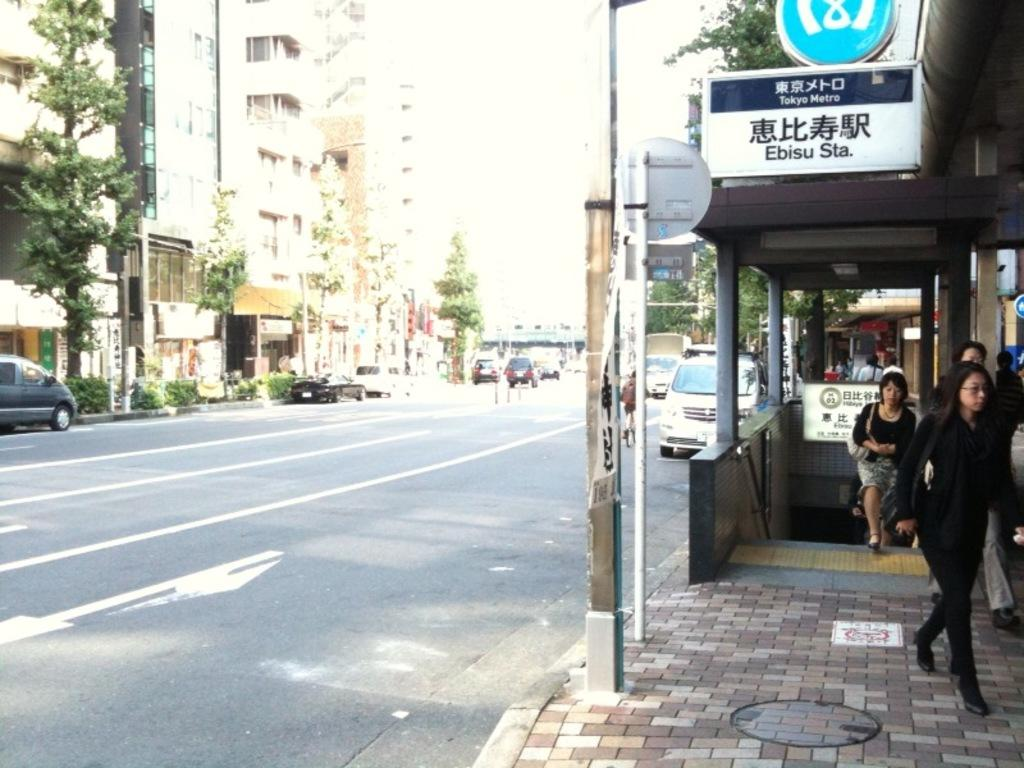<image>
Describe the image concisely. A group of people walk up from the Ebisu Subway Station in Japan. 